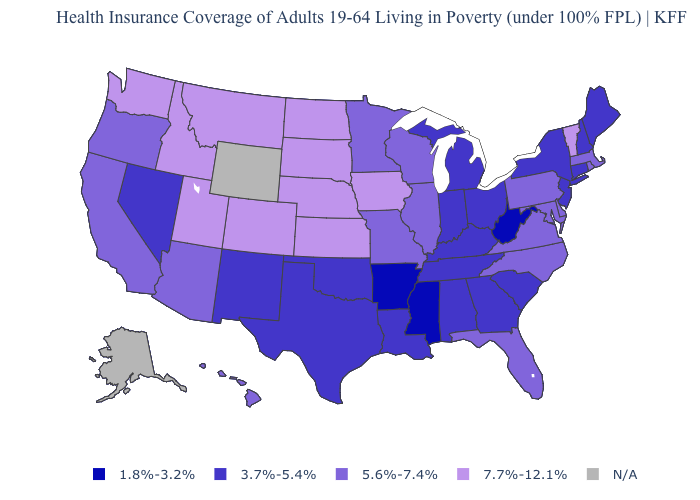Name the states that have a value in the range N/A?
Short answer required. Alaska, Wyoming. What is the lowest value in states that border Connecticut?
Write a very short answer. 3.7%-5.4%. What is the value of Wyoming?
Short answer required. N/A. What is the value of Alabama?
Answer briefly. 3.7%-5.4%. Name the states that have a value in the range 5.6%-7.4%?
Concise answer only. Arizona, California, Delaware, Florida, Hawaii, Illinois, Maryland, Massachusetts, Minnesota, Missouri, North Carolina, Oregon, Pennsylvania, Rhode Island, Virginia, Wisconsin. What is the value of Maryland?
Keep it brief. 5.6%-7.4%. How many symbols are there in the legend?
Be succinct. 5. Name the states that have a value in the range 5.6%-7.4%?
Answer briefly. Arizona, California, Delaware, Florida, Hawaii, Illinois, Maryland, Massachusetts, Minnesota, Missouri, North Carolina, Oregon, Pennsylvania, Rhode Island, Virginia, Wisconsin. Name the states that have a value in the range 5.6%-7.4%?
Be succinct. Arizona, California, Delaware, Florida, Hawaii, Illinois, Maryland, Massachusetts, Minnesota, Missouri, North Carolina, Oregon, Pennsylvania, Rhode Island, Virginia, Wisconsin. Name the states that have a value in the range 3.7%-5.4%?
Answer briefly. Alabama, Connecticut, Georgia, Indiana, Kentucky, Louisiana, Maine, Michigan, Nevada, New Hampshire, New Jersey, New Mexico, New York, Ohio, Oklahoma, South Carolina, Tennessee, Texas. What is the value of Maryland?
Quick response, please. 5.6%-7.4%. Name the states that have a value in the range 7.7%-12.1%?
Quick response, please. Colorado, Idaho, Iowa, Kansas, Montana, Nebraska, North Dakota, South Dakota, Utah, Vermont, Washington. Name the states that have a value in the range 1.8%-3.2%?
Be succinct. Arkansas, Mississippi, West Virginia. Which states have the lowest value in the West?
Give a very brief answer. Nevada, New Mexico. Does Minnesota have the lowest value in the MidWest?
Keep it brief. No. 